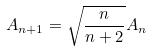<formula> <loc_0><loc_0><loc_500><loc_500>A _ { n + 1 } = \sqrt { \frac { n } { n + 2 } } A _ { n }</formula> 